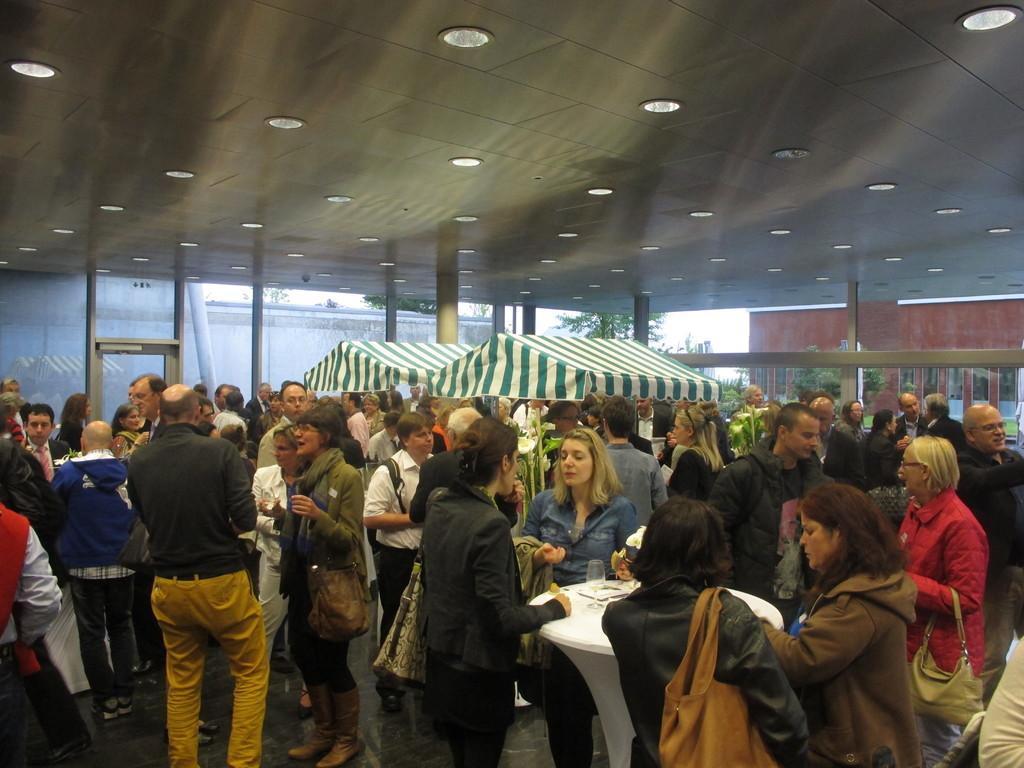Please provide a concise description of this image. In this image, we can see many people and some tables and tents. In the background, we can see trees. At the top, there are lights. 